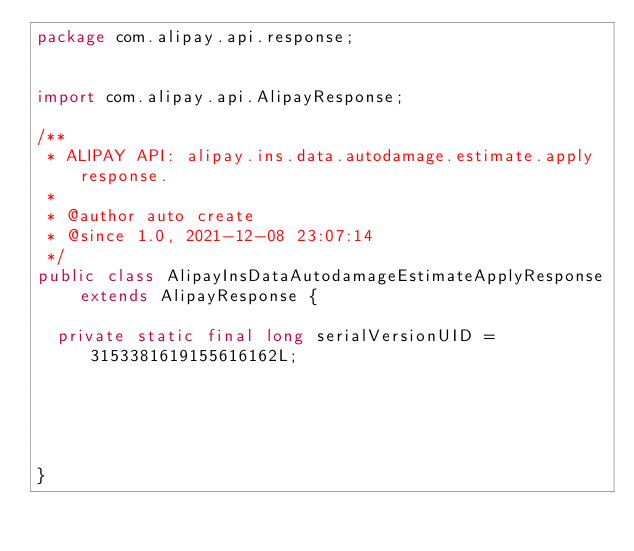<code> <loc_0><loc_0><loc_500><loc_500><_Java_>package com.alipay.api.response;


import com.alipay.api.AlipayResponse;

/**
 * ALIPAY API: alipay.ins.data.autodamage.estimate.apply response.
 * 
 * @author auto create
 * @since 1.0, 2021-12-08 23:07:14
 */
public class AlipayInsDataAutodamageEstimateApplyResponse extends AlipayResponse {

	private static final long serialVersionUID = 3153381619155616162L;

	

	

}
</code> 